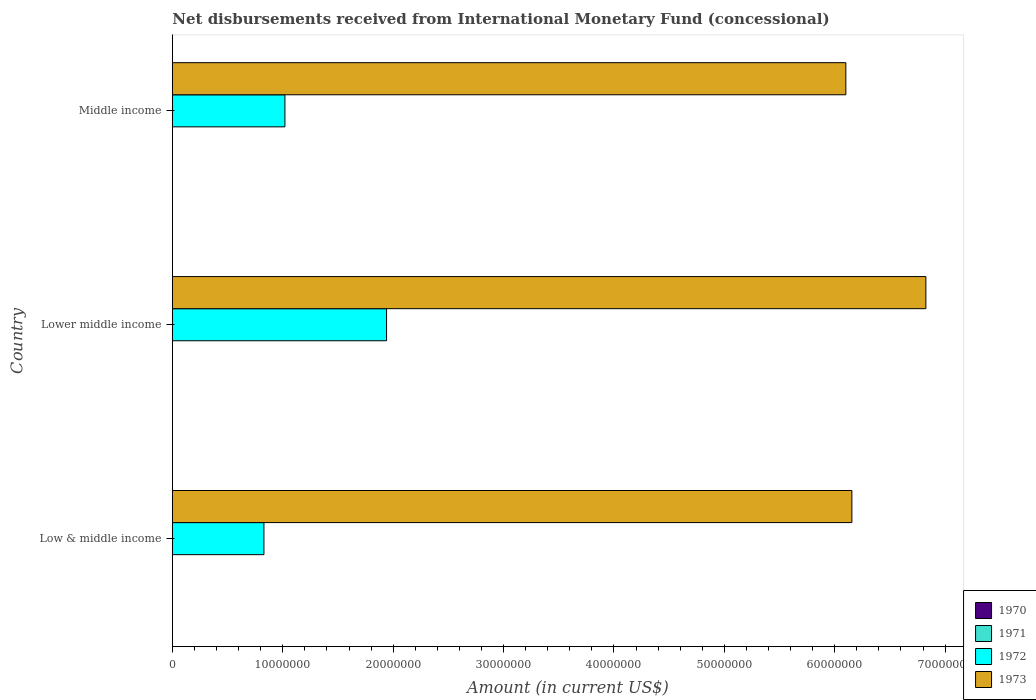Are the number of bars on each tick of the Y-axis equal?
Offer a terse response. Yes. How many bars are there on the 2nd tick from the bottom?
Give a very brief answer. 2. What is the label of the 1st group of bars from the top?
Ensure brevity in your answer.  Middle income. What is the amount of disbursements received from International Monetary Fund in 1972 in Middle income?
Your answer should be very brief. 1.02e+07. Across all countries, what is the maximum amount of disbursements received from International Monetary Fund in 1973?
Offer a terse response. 6.83e+07. In which country was the amount of disbursements received from International Monetary Fund in 1972 maximum?
Offer a very short reply. Lower middle income. What is the total amount of disbursements received from International Monetary Fund in 1972 in the graph?
Your answer should be very brief. 3.79e+07. What is the difference between the amount of disbursements received from International Monetary Fund in 1973 in Lower middle income and that in Middle income?
Offer a very short reply. 7.25e+06. What is the difference between the amount of disbursements received from International Monetary Fund in 1972 in Lower middle income and the amount of disbursements received from International Monetary Fund in 1971 in Middle income?
Keep it short and to the point. 1.94e+07. What is the average amount of disbursements received from International Monetary Fund in 1973 per country?
Provide a short and direct response. 6.36e+07. In how many countries, is the amount of disbursements received from International Monetary Fund in 1972 greater than 8000000 US$?
Your response must be concise. 3. What is the ratio of the amount of disbursements received from International Monetary Fund in 1973 in Low & middle income to that in Middle income?
Ensure brevity in your answer.  1.01. What is the difference between the highest and the second highest amount of disbursements received from International Monetary Fund in 1972?
Provide a short and direct response. 9.21e+06. What is the difference between the highest and the lowest amount of disbursements received from International Monetary Fund in 1972?
Offer a terse response. 1.11e+07. In how many countries, is the amount of disbursements received from International Monetary Fund in 1971 greater than the average amount of disbursements received from International Monetary Fund in 1971 taken over all countries?
Offer a very short reply. 0. Is the sum of the amount of disbursements received from International Monetary Fund in 1972 in Low & middle income and Middle income greater than the maximum amount of disbursements received from International Monetary Fund in 1973 across all countries?
Offer a very short reply. No. Is it the case that in every country, the sum of the amount of disbursements received from International Monetary Fund in 1973 and amount of disbursements received from International Monetary Fund in 1970 is greater than the sum of amount of disbursements received from International Monetary Fund in 1972 and amount of disbursements received from International Monetary Fund in 1971?
Offer a terse response. Yes. Is it the case that in every country, the sum of the amount of disbursements received from International Monetary Fund in 1970 and amount of disbursements received from International Monetary Fund in 1971 is greater than the amount of disbursements received from International Monetary Fund in 1972?
Your response must be concise. No. How many bars are there?
Give a very brief answer. 6. Are all the bars in the graph horizontal?
Your answer should be very brief. Yes. How many countries are there in the graph?
Provide a short and direct response. 3. Are the values on the major ticks of X-axis written in scientific E-notation?
Your response must be concise. No. Does the graph contain grids?
Your answer should be compact. No. How many legend labels are there?
Your response must be concise. 4. How are the legend labels stacked?
Offer a terse response. Vertical. What is the title of the graph?
Provide a short and direct response. Net disbursements received from International Monetary Fund (concessional). Does "1964" appear as one of the legend labels in the graph?
Your response must be concise. No. What is the label or title of the X-axis?
Your answer should be very brief. Amount (in current US$). What is the Amount (in current US$) in 1970 in Low & middle income?
Your answer should be compact. 0. What is the Amount (in current US$) in 1972 in Low & middle income?
Ensure brevity in your answer.  8.30e+06. What is the Amount (in current US$) of 1973 in Low & middle income?
Keep it short and to the point. 6.16e+07. What is the Amount (in current US$) of 1970 in Lower middle income?
Provide a succinct answer. 0. What is the Amount (in current US$) of 1972 in Lower middle income?
Provide a succinct answer. 1.94e+07. What is the Amount (in current US$) in 1973 in Lower middle income?
Provide a succinct answer. 6.83e+07. What is the Amount (in current US$) in 1972 in Middle income?
Offer a very short reply. 1.02e+07. What is the Amount (in current US$) in 1973 in Middle income?
Make the answer very short. 6.10e+07. Across all countries, what is the maximum Amount (in current US$) in 1972?
Provide a short and direct response. 1.94e+07. Across all countries, what is the maximum Amount (in current US$) of 1973?
Your answer should be very brief. 6.83e+07. Across all countries, what is the minimum Amount (in current US$) in 1972?
Make the answer very short. 8.30e+06. Across all countries, what is the minimum Amount (in current US$) in 1973?
Ensure brevity in your answer.  6.10e+07. What is the total Amount (in current US$) of 1970 in the graph?
Your answer should be compact. 0. What is the total Amount (in current US$) in 1971 in the graph?
Your answer should be compact. 0. What is the total Amount (in current US$) of 1972 in the graph?
Your answer should be compact. 3.79e+07. What is the total Amount (in current US$) in 1973 in the graph?
Your answer should be compact. 1.91e+08. What is the difference between the Amount (in current US$) in 1972 in Low & middle income and that in Lower middle income?
Your response must be concise. -1.11e+07. What is the difference between the Amount (in current US$) in 1973 in Low & middle income and that in Lower middle income?
Offer a terse response. -6.70e+06. What is the difference between the Amount (in current US$) in 1972 in Low & middle income and that in Middle income?
Make the answer very short. -1.90e+06. What is the difference between the Amount (in current US$) in 1973 in Low & middle income and that in Middle income?
Provide a short and direct response. 5.46e+05. What is the difference between the Amount (in current US$) of 1972 in Lower middle income and that in Middle income?
Offer a terse response. 9.21e+06. What is the difference between the Amount (in current US$) of 1973 in Lower middle income and that in Middle income?
Make the answer very short. 7.25e+06. What is the difference between the Amount (in current US$) in 1972 in Low & middle income and the Amount (in current US$) in 1973 in Lower middle income?
Your answer should be compact. -6.00e+07. What is the difference between the Amount (in current US$) in 1972 in Low & middle income and the Amount (in current US$) in 1973 in Middle income?
Your answer should be compact. -5.27e+07. What is the difference between the Amount (in current US$) in 1972 in Lower middle income and the Amount (in current US$) in 1973 in Middle income?
Your answer should be compact. -4.16e+07. What is the average Amount (in current US$) of 1972 per country?
Offer a very short reply. 1.26e+07. What is the average Amount (in current US$) in 1973 per country?
Your answer should be very brief. 6.36e+07. What is the difference between the Amount (in current US$) in 1972 and Amount (in current US$) in 1973 in Low & middle income?
Offer a very short reply. -5.33e+07. What is the difference between the Amount (in current US$) in 1972 and Amount (in current US$) in 1973 in Lower middle income?
Keep it short and to the point. -4.89e+07. What is the difference between the Amount (in current US$) of 1972 and Amount (in current US$) of 1973 in Middle income?
Your answer should be very brief. -5.08e+07. What is the ratio of the Amount (in current US$) of 1972 in Low & middle income to that in Lower middle income?
Keep it short and to the point. 0.43. What is the ratio of the Amount (in current US$) of 1973 in Low & middle income to that in Lower middle income?
Ensure brevity in your answer.  0.9. What is the ratio of the Amount (in current US$) in 1972 in Low & middle income to that in Middle income?
Your response must be concise. 0.81. What is the ratio of the Amount (in current US$) in 1973 in Low & middle income to that in Middle income?
Keep it short and to the point. 1.01. What is the ratio of the Amount (in current US$) of 1972 in Lower middle income to that in Middle income?
Ensure brevity in your answer.  1.9. What is the ratio of the Amount (in current US$) of 1973 in Lower middle income to that in Middle income?
Your answer should be compact. 1.12. What is the difference between the highest and the second highest Amount (in current US$) of 1972?
Give a very brief answer. 9.21e+06. What is the difference between the highest and the second highest Amount (in current US$) in 1973?
Keep it short and to the point. 6.70e+06. What is the difference between the highest and the lowest Amount (in current US$) in 1972?
Your answer should be compact. 1.11e+07. What is the difference between the highest and the lowest Amount (in current US$) of 1973?
Provide a succinct answer. 7.25e+06. 